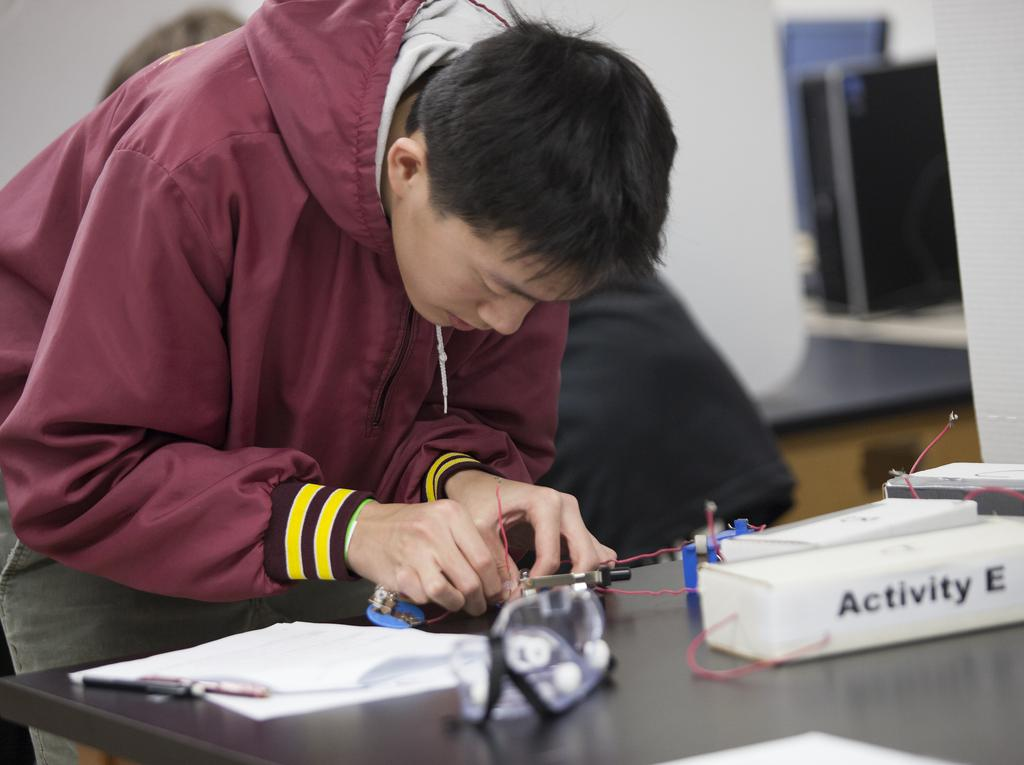What is the main subject of the image? There is a man in the image. What is the man holding in his hand? The man is holding wires in his hand. What can be seen on the left side of the image? There are pens and papers on the table on the left side of the image. What is located on the right side of the image? There is a desktop and a CPU on the right side of the image. What type of punishment is being administered to the man in the image? There is no indication of punishment in the image; the man is simply holding wires in his hand. What color is the paint on the desktop in the image? There is no paint visible on the desktop in the image. 